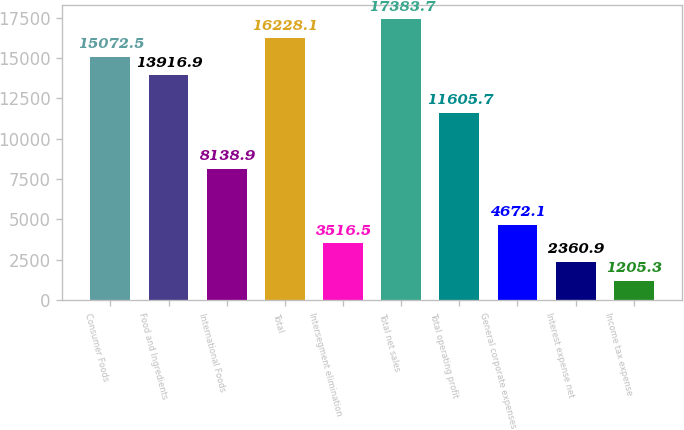<chart> <loc_0><loc_0><loc_500><loc_500><bar_chart><fcel>Consumer Foods<fcel>Food and Ingredients<fcel>International Foods<fcel>Total<fcel>Intersegment elimination<fcel>Total net sales<fcel>Total operating profit<fcel>General corporate expenses<fcel>Interest expense net<fcel>Income tax expense<nl><fcel>15072.5<fcel>13916.9<fcel>8138.9<fcel>16228.1<fcel>3516.5<fcel>17383.7<fcel>11605.7<fcel>4672.1<fcel>2360.9<fcel>1205.3<nl></chart> 